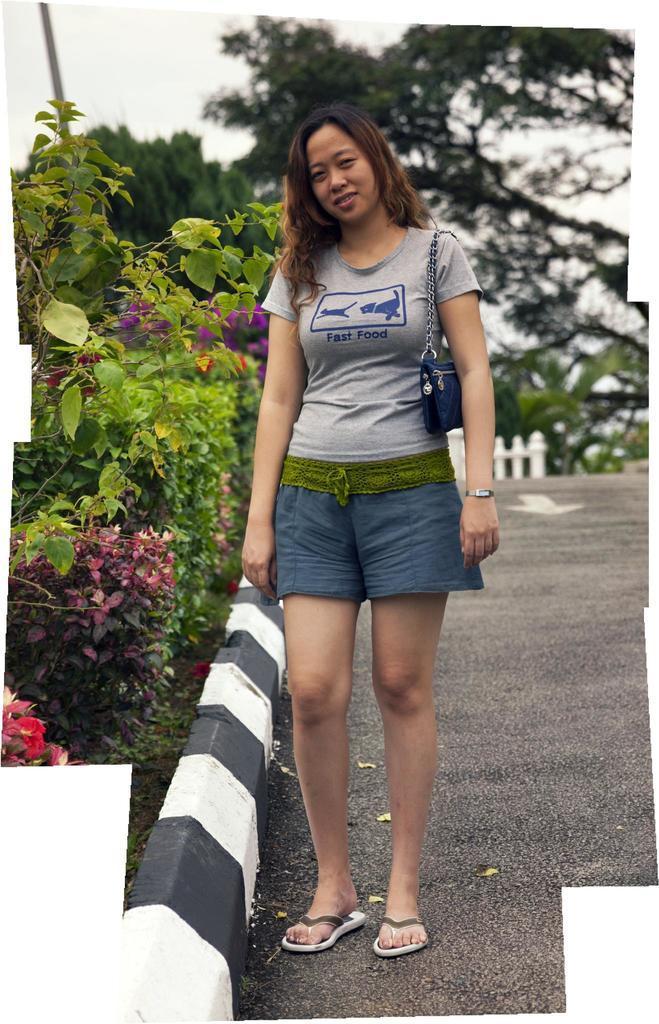Describe this image in one or two sentences. Here we can see a woman standing on a road by holding a bag on her shoulder. On the left we can see plants and among them we can see a plant with flowers on the ground. In the background there is a pole,fence,trees and sky. 